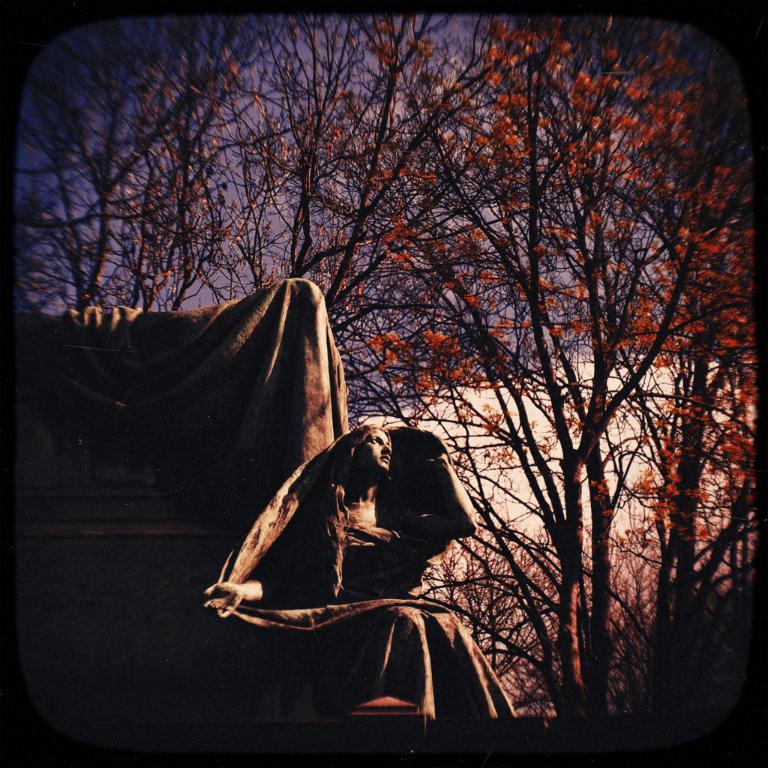What is the main subject of the image? There is a statue of a woman in the image. What can be seen in the background of the image? There are trees in the background of the image. What is special about the trees in the image? The trees have orange color flowers on them. What type of digestion system does the statue have in the image? The statue is not a living being and therefore does not have a digestion system. 